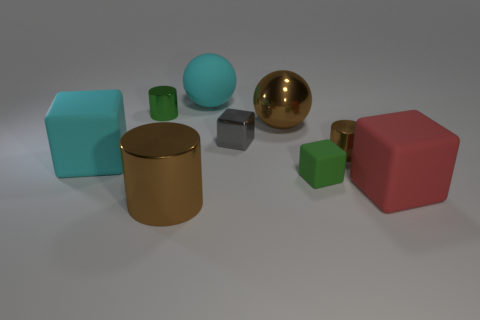Subtract all cylinders. How many objects are left? 6 Add 1 tiny yellow rubber objects. How many objects exist? 10 Add 1 cyan blocks. How many cyan blocks are left? 2 Add 6 large brown rubber cylinders. How many large brown rubber cylinders exist? 6 Subtract 0 gray cylinders. How many objects are left? 9 Subtract all cyan cubes. Subtract all red matte cubes. How many objects are left? 7 